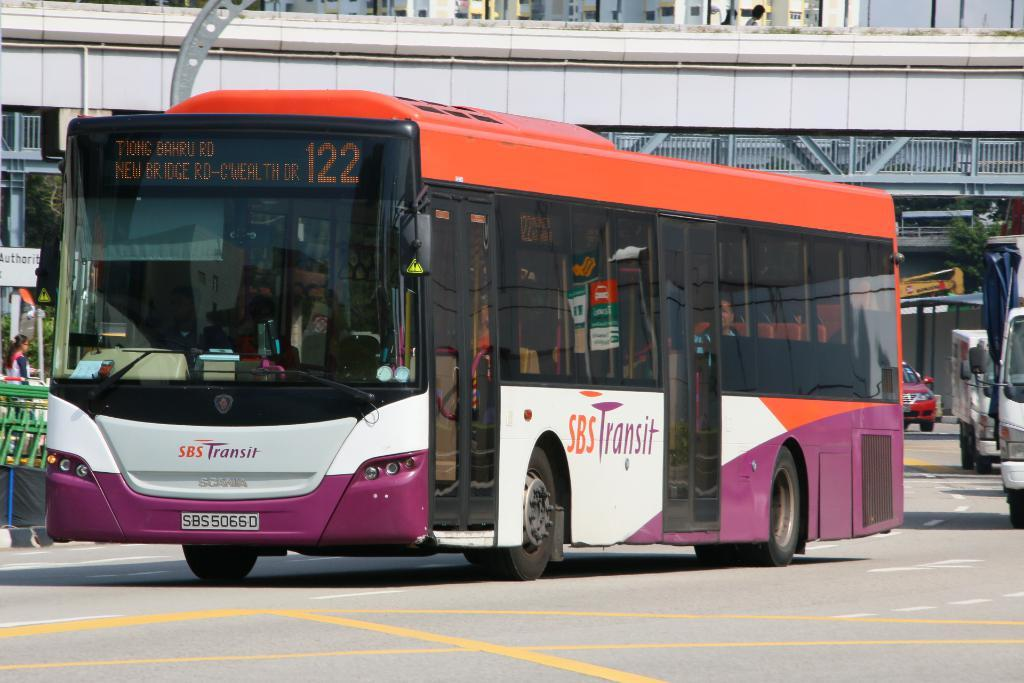<image>
Render a clear and concise summary of the photo. A colorful bus which is run by SBS transit. 